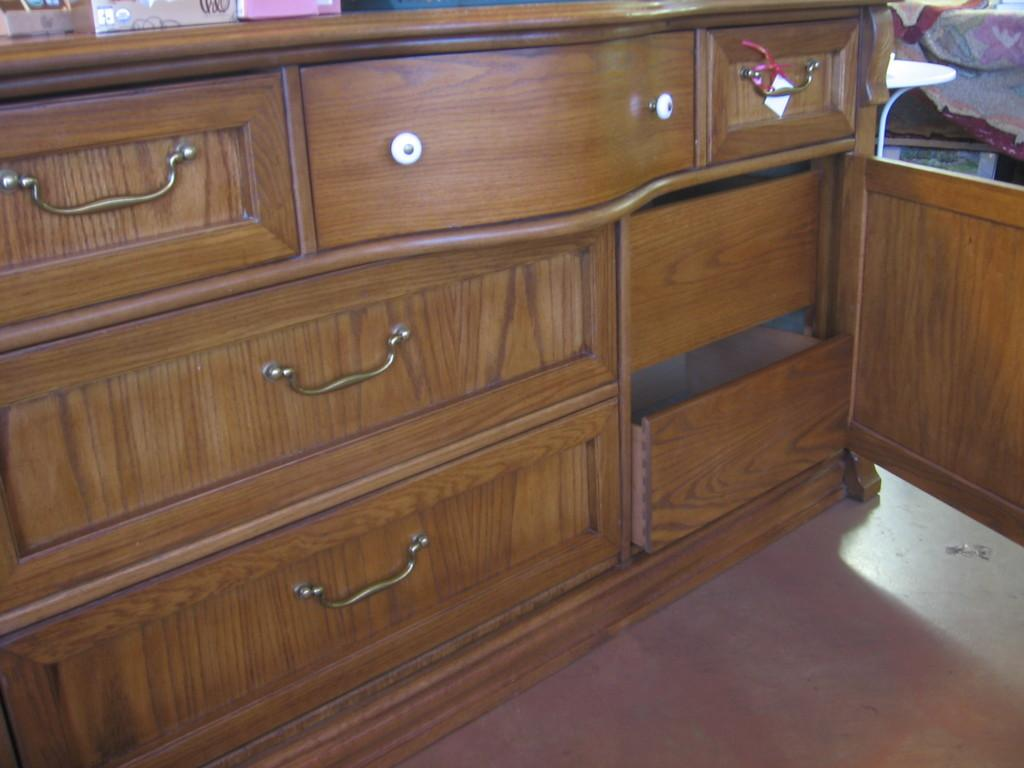What type of furniture is present in the image? There is a cupboard with draws in the image. What can be seen on top of the cupboard? There are objects on the cupboard. What is located to the right of the cupboard? There is a cloth to the right of the cupboard. What type of gun is visible on the cupboard in the image? There is no gun present in the image; only a cupboard with draws, objects on the cupboard, and a cloth to the right of the cupboard are visible. 